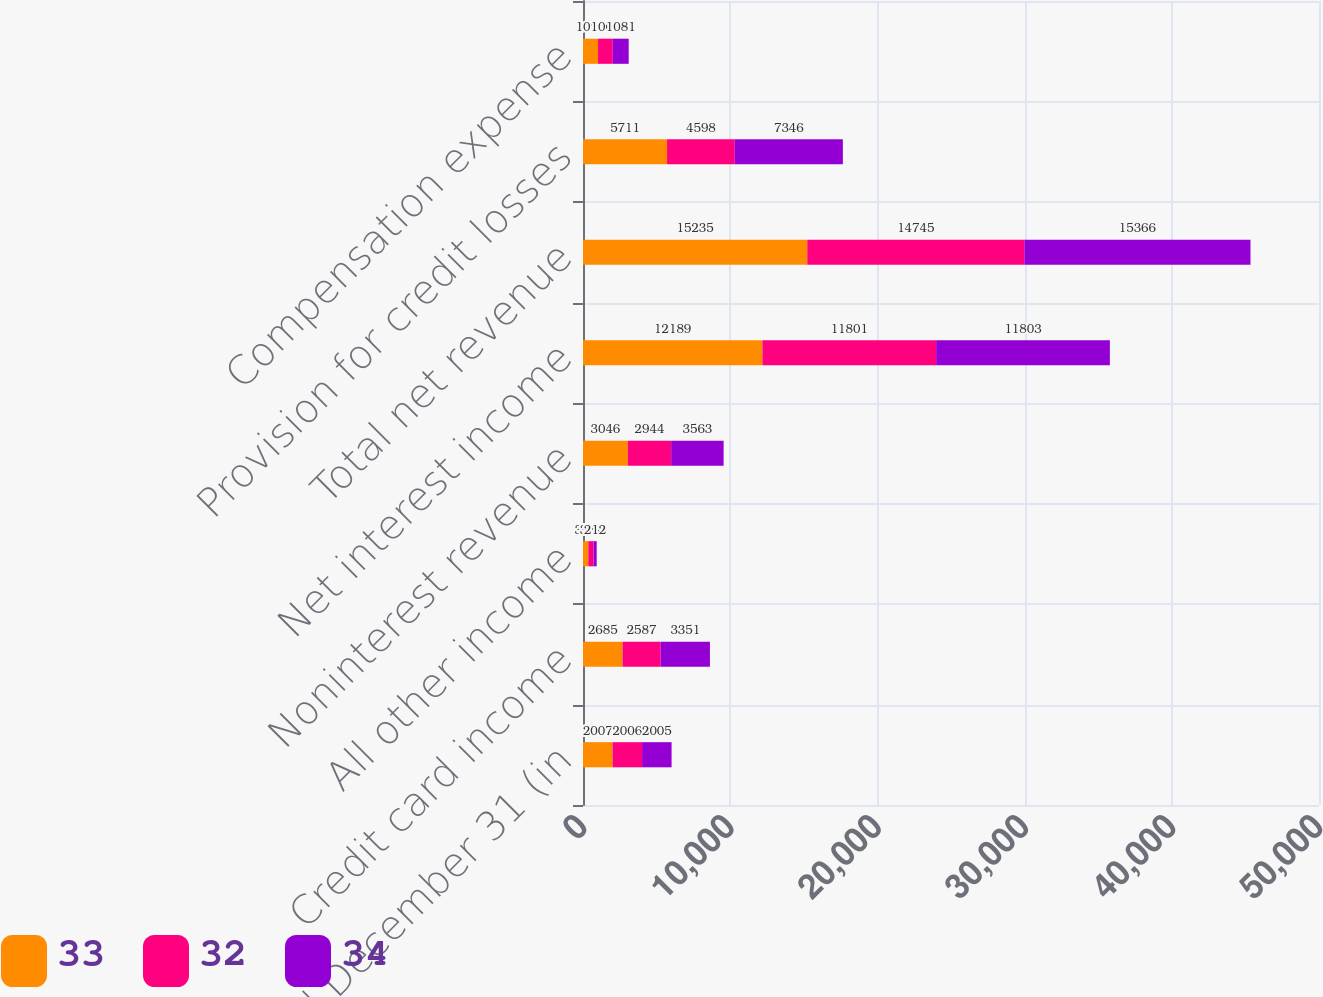Convert chart. <chart><loc_0><loc_0><loc_500><loc_500><stacked_bar_chart><ecel><fcel>Year ended December 31 (in<fcel>Credit card income<fcel>All other income<fcel>Noninterest revenue<fcel>Net interest income<fcel>Total net revenue<fcel>Provision for credit losses<fcel>Compensation expense<nl><fcel>33<fcel>2007<fcel>2685<fcel>361<fcel>3046<fcel>12189<fcel>15235<fcel>5711<fcel>1021<nl><fcel>32<fcel>2006<fcel>2587<fcel>357<fcel>2944<fcel>11801<fcel>14745<fcel>4598<fcel>1003<nl><fcel>34<fcel>2005<fcel>3351<fcel>212<fcel>3563<fcel>11803<fcel>15366<fcel>7346<fcel>1081<nl></chart> 